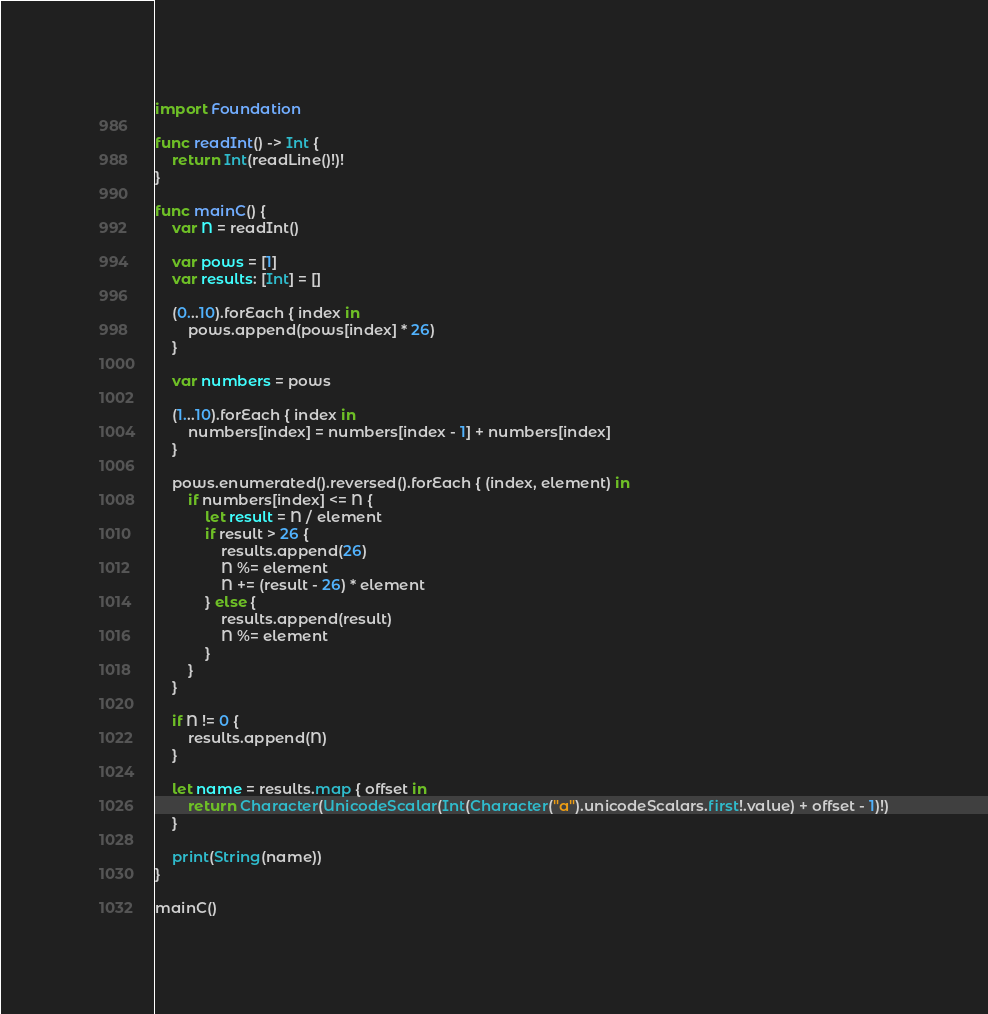<code> <loc_0><loc_0><loc_500><loc_500><_Swift_>import Foundation

func readInt() -> Int {
    return Int(readLine()!)!
}

func mainC() {
    var N = readInt()

    var pows = [1]
    var results: [Int] = []

    (0...10).forEach { index in
        pows.append(pows[index] * 26)
    }

    var numbers = pows

    (1...10).forEach { index in
        numbers[index] = numbers[index - 1] + numbers[index]
    }

    pows.enumerated().reversed().forEach { (index, element) in
        if numbers[index] <= N {
            let result = N / element
            if result > 26 {
                results.append(26)
                N %= element
                N += (result - 26) * element
            } else {
                results.append(result)
                N %= element
            }
        }
    }

    if N != 0 {
        results.append(N)
    }

    let name = results.map { offset in
        return Character(UnicodeScalar(Int(Character("a").unicodeScalars.first!.value) + offset - 1)!)
    }

    print(String(name))
}

mainC()</code> 